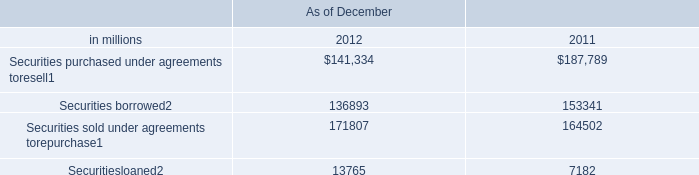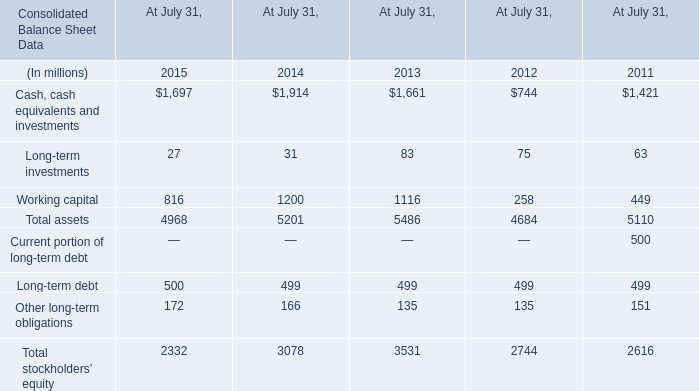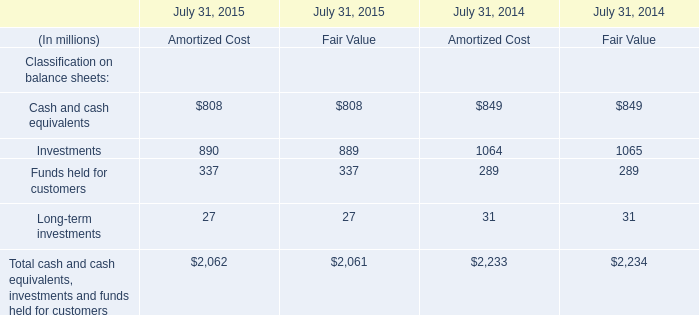between december 2012 and december 2011 , what was the change in billions in the amount of securities borrowed? 
Computations: (38.40 - 47.62)
Answer: -9.22. 